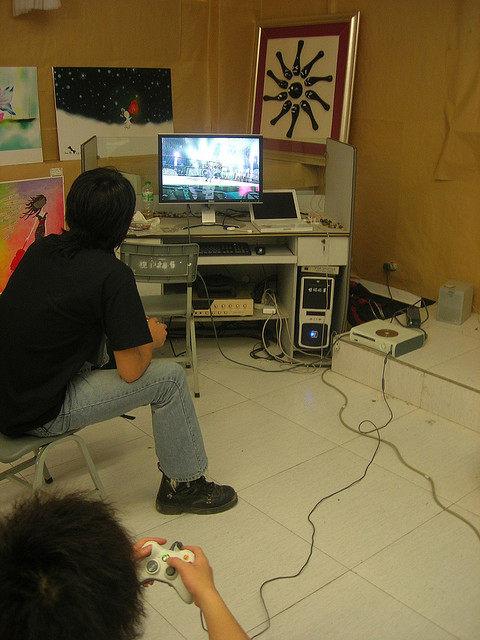What can you tell about the room based on the decor and setup? The room appears to be a personal or recreational space dedicated to gaming and creativity. The desk is equipped with a computer and various gaming peripherals, indicating a setup designed for serious gaming sessions. The presence of multiple artworks on the walls hints at an environment that values creativity and maybe the personal touch of the inhabitants. This blend of functionality and aesthetics suggests a thoughtfully designed space where gaming and art coexist harmoniously. Why do you think the room has this specific setup and decor? The specific setup and decor of the room indicate a passion for both gaming and creativity. The meticulously arranged gadgets and peripherals at the desk suggest that gaming is more than just a casual hobby, possibly indicating a competitive or serious gamer. The artworks on the walls highlight an appreciation for art and personal expression, suggesting that the individual who uses this room values a balanced environment where both technical and creative interests can thrive. This mix of gaming and artistic elements creates a unique space that caters to the user's multifaceted interests. 